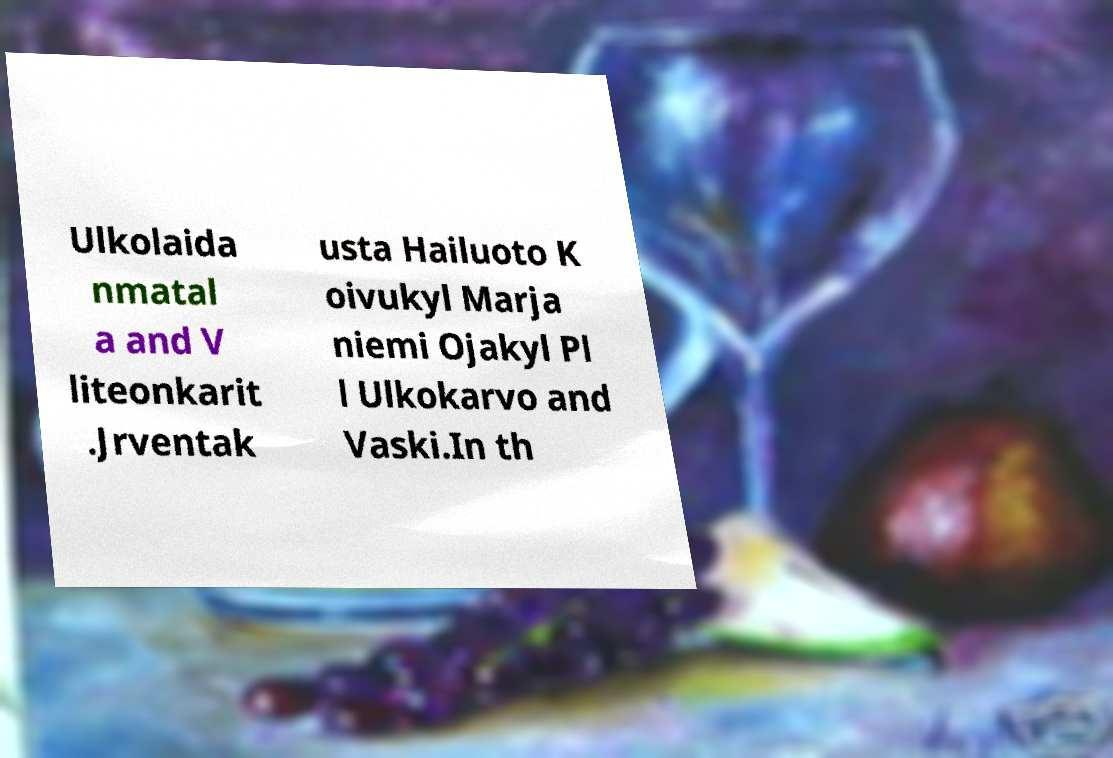Can you accurately transcribe the text from the provided image for me? Ulkolaida nmatal a and V liteonkarit .Jrventak usta Hailuoto K oivukyl Marja niemi Ojakyl Pl l Ulkokarvo and Vaski.In th 